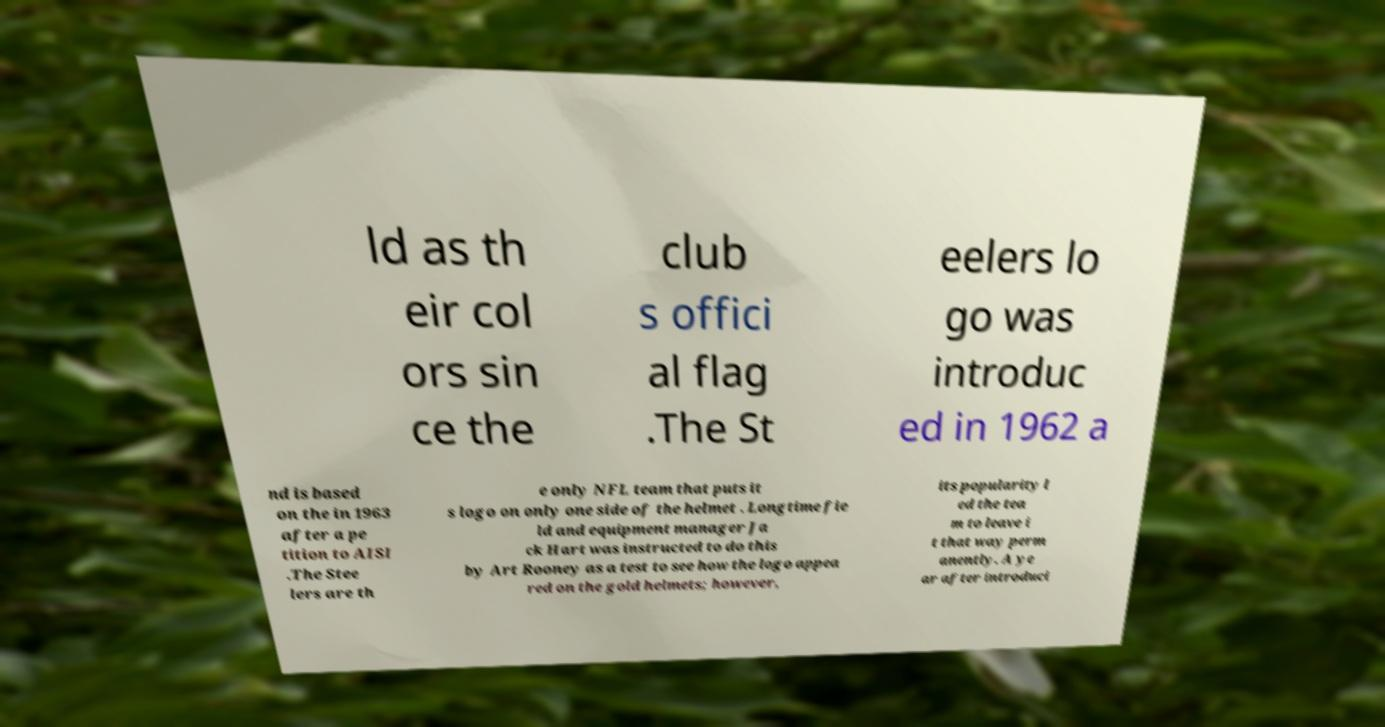Please identify and transcribe the text found in this image. ld as th eir col ors sin ce the club s offici al flag .The St eelers lo go was introduc ed in 1962 a nd is based on the in 1963 after a pe tition to AISI .The Stee lers are th e only NFL team that puts it s logo on only one side of the helmet . Longtime fie ld and equipment manager Ja ck Hart was instructed to do this by Art Rooney as a test to see how the logo appea red on the gold helmets; however, its popularity l ed the tea m to leave i t that way perm anently. A ye ar after introduci 